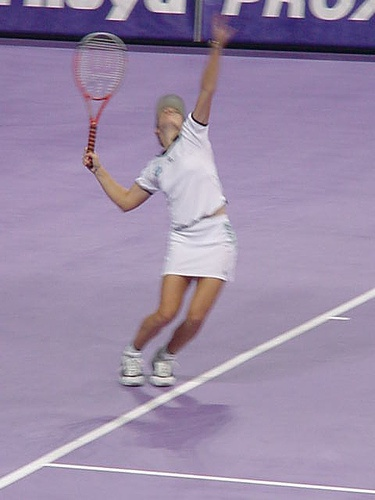Describe the objects in this image and their specific colors. I can see people in lightgray, lavender, darkgray, and gray tones and tennis racket in lightgray, gray, and brown tones in this image. 